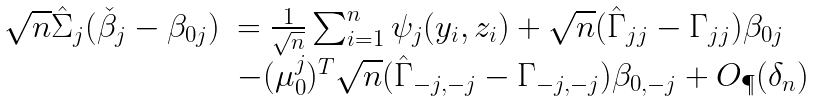Convert formula to latex. <formula><loc_0><loc_0><loc_500><loc_500>\begin{array} { r l } \sqrt { n } \hat { \Sigma } _ { j } ( \check { \beta } _ { j } - \beta _ { 0 j } ) & = \frac { 1 } { \sqrt { n } } \sum _ { i = 1 } ^ { n } \psi _ { j } ( y _ { i } , z _ { i } ) + \sqrt { n } ( \hat { \Gamma } _ { j j } - \Gamma _ { j j } ) \beta _ { 0 j } \\ & - ( \mu ^ { j } _ { 0 } ) ^ { T } \sqrt { n } ( \hat { \Gamma } _ { - j , - j } - \Gamma _ { - j , - j } ) \beta _ { 0 , - j } + O _ { \P } ( \delta _ { n } ) \end{array}</formula> 